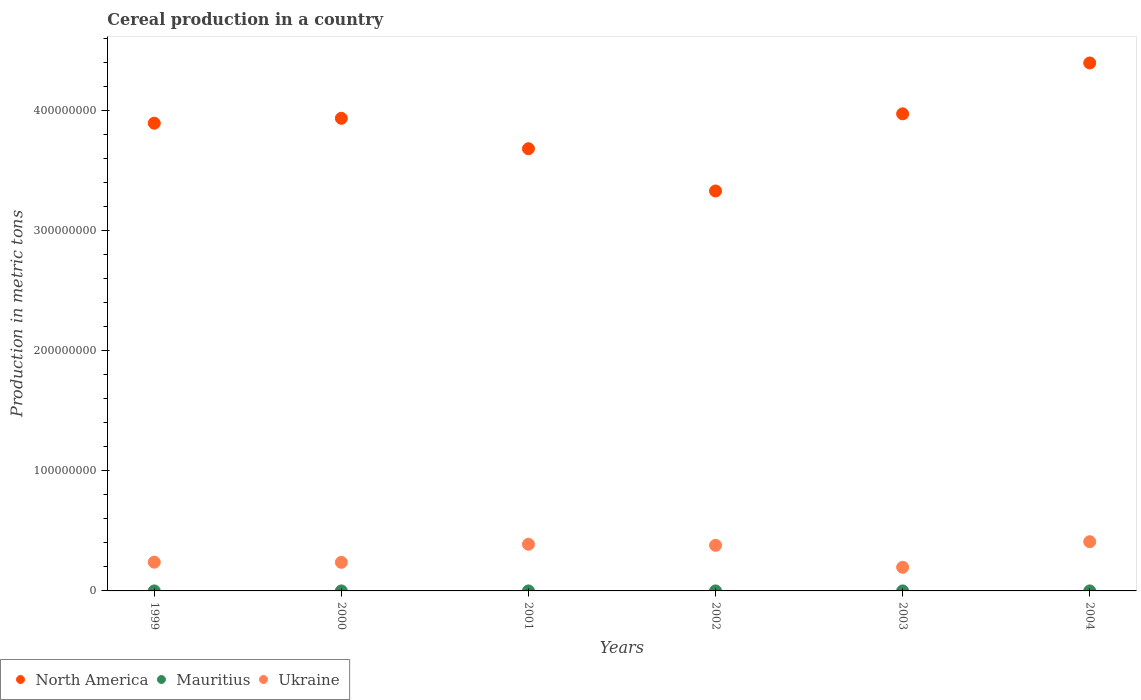What is the total cereal production in Ukraine in 2002?
Provide a short and direct response. 3.80e+07. Across all years, what is the maximum total cereal production in North America?
Ensure brevity in your answer.  4.40e+08. Across all years, what is the minimum total cereal production in North America?
Your answer should be compact. 3.33e+08. In which year was the total cereal production in Mauritius maximum?
Provide a short and direct response. 2000. What is the total total cereal production in Mauritius in the graph?
Offer a terse response. 2054. What is the difference between the total cereal production in Ukraine in 2002 and that in 2004?
Ensure brevity in your answer.  -3.00e+06. What is the difference between the total cereal production in Mauritius in 2003 and the total cereal production in North America in 1999?
Provide a succinct answer. -3.90e+08. What is the average total cereal production in Ukraine per year?
Your answer should be compact. 3.09e+07. In the year 2001, what is the difference between the total cereal production in Ukraine and total cereal production in North America?
Your response must be concise. -3.29e+08. What is the ratio of the total cereal production in Ukraine in 1999 to that in 2003?
Offer a very short reply. 1.22. Is the total cereal production in North America in 2000 less than that in 2004?
Your response must be concise. Yes. Is the difference between the total cereal production in Ukraine in 1999 and 2000 greater than the difference between the total cereal production in North America in 1999 and 2000?
Your response must be concise. Yes. What is the difference between the highest and the second highest total cereal production in Ukraine?
Make the answer very short. 2.12e+06. What is the difference between the highest and the lowest total cereal production in North America?
Your answer should be very brief. 1.07e+08. In how many years, is the total cereal production in Ukraine greater than the average total cereal production in Ukraine taken over all years?
Give a very brief answer. 3. Is the sum of the total cereal production in Mauritius in 2000 and 2004 greater than the maximum total cereal production in Ukraine across all years?
Give a very brief answer. No. Is it the case that in every year, the sum of the total cereal production in Ukraine and total cereal production in Mauritius  is greater than the total cereal production in North America?
Your response must be concise. No. Does the total cereal production in North America monotonically increase over the years?
Your response must be concise. No. What is the difference between two consecutive major ticks on the Y-axis?
Your answer should be compact. 1.00e+08. Are the values on the major ticks of Y-axis written in scientific E-notation?
Your response must be concise. No. Where does the legend appear in the graph?
Your response must be concise. Bottom left. What is the title of the graph?
Your answer should be very brief. Cereal production in a country. Does "Senegal" appear as one of the legend labels in the graph?
Offer a terse response. No. What is the label or title of the X-axis?
Offer a terse response. Years. What is the label or title of the Y-axis?
Your response must be concise. Production in metric tons. What is the Production in metric tons in North America in 1999?
Provide a succinct answer. 3.90e+08. What is the Production in metric tons of Mauritius in 1999?
Give a very brief answer. 201. What is the Production in metric tons of Ukraine in 1999?
Give a very brief answer. 2.39e+07. What is the Production in metric tons in North America in 2000?
Give a very brief answer. 3.94e+08. What is the Production in metric tons in Mauritius in 2000?
Provide a short and direct response. 623. What is the Production in metric tons in Ukraine in 2000?
Make the answer very short. 2.38e+07. What is the Production in metric tons of North America in 2001?
Keep it short and to the point. 3.68e+08. What is the Production in metric tons of Mauritius in 2001?
Your answer should be compact. 389. What is the Production in metric tons in Ukraine in 2001?
Your response must be concise. 3.89e+07. What is the Production in metric tons in North America in 2002?
Offer a very short reply. 3.33e+08. What is the Production in metric tons in Mauritius in 2002?
Your response must be concise. 295. What is the Production in metric tons in Ukraine in 2002?
Offer a terse response. 3.80e+07. What is the Production in metric tons in North America in 2003?
Offer a terse response. 3.97e+08. What is the Production in metric tons of Mauritius in 2003?
Offer a terse response. 177. What is the Production in metric tons in Ukraine in 2003?
Keep it short and to the point. 1.97e+07. What is the Production in metric tons in North America in 2004?
Give a very brief answer. 4.40e+08. What is the Production in metric tons of Mauritius in 2004?
Make the answer very short. 369. What is the Production in metric tons in Ukraine in 2004?
Your response must be concise. 4.10e+07. Across all years, what is the maximum Production in metric tons in North America?
Provide a succinct answer. 4.40e+08. Across all years, what is the maximum Production in metric tons of Mauritius?
Your response must be concise. 623. Across all years, what is the maximum Production in metric tons of Ukraine?
Your response must be concise. 4.10e+07. Across all years, what is the minimum Production in metric tons of North America?
Make the answer very short. 3.33e+08. Across all years, what is the minimum Production in metric tons of Mauritius?
Provide a short and direct response. 177. Across all years, what is the minimum Production in metric tons in Ukraine?
Offer a very short reply. 1.97e+07. What is the total Production in metric tons of North America in the graph?
Offer a very short reply. 2.32e+09. What is the total Production in metric tons in Mauritius in the graph?
Make the answer very short. 2054. What is the total Production in metric tons in Ukraine in the graph?
Your answer should be very brief. 1.85e+08. What is the difference between the Production in metric tons in North America in 1999 and that in 2000?
Ensure brevity in your answer.  -4.09e+06. What is the difference between the Production in metric tons in Mauritius in 1999 and that in 2000?
Offer a terse response. -422. What is the difference between the Production in metric tons of Ukraine in 1999 and that in 2000?
Offer a very short reply. 1.43e+05. What is the difference between the Production in metric tons of North America in 1999 and that in 2001?
Provide a succinct answer. 2.13e+07. What is the difference between the Production in metric tons in Mauritius in 1999 and that in 2001?
Ensure brevity in your answer.  -188. What is the difference between the Production in metric tons of Ukraine in 1999 and that in 2001?
Your answer should be compact. -1.49e+07. What is the difference between the Production in metric tons of North America in 1999 and that in 2002?
Ensure brevity in your answer.  5.65e+07. What is the difference between the Production in metric tons in Mauritius in 1999 and that in 2002?
Your response must be concise. -94. What is the difference between the Production in metric tons of Ukraine in 1999 and that in 2002?
Provide a short and direct response. -1.40e+07. What is the difference between the Production in metric tons in North America in 1999 and that in 2003?
Provide a short and direct response. -7.80e+06. What is the difference between the Production in metric tons of Mauritius in 1999 and that in 2003?
Ensure brevity in your answer.  24. What is the difference between the Production in metric tons of Ukraine in 1999 and that in 2003?
Offer a very short reply. 4.29e+06. What is the difference between the Production in metric tons in North America in 1999 and that in 2004?
Your answer should be very brief. -5.02e+07. What is the difference between the Production in metric tons of Mauritius in 1999 and that in 2004?
Provide a short and direct response. -168. What is the difference between the Production in metric tons in Ukraine in 1999 and that in 2004?
Provide a succinct answer. -1.70e+07. What is the difference between the Production in metric tons of North America in 2000 and that in 2001?
Provide a short and direct response. 2.53e+07. What is the difference between the Production in metric tons of Mauritius in 2000 and that in 2001?
Provide a succinct answer. 234. What is the difference between the Production in metric tons of Ukraine in 2000 and that in 2001?
Keep it short and to the point. -1.51e+07. What is the difference between the Production in metric tons in North America in 2000 and that in 2002?
Provide a succinct answer. 6.05e+07. What is the difference between the Production in metric tons in Mauritius in 2000 and that in 2002?
Make the answer very short. 328. What is the difference between the Production in metric tons of Ukraine in 2000 and that in 2002?
Provide a succinct answer. -1.42e+07. What is the difference between the Production in metric tons in North America in 2000 and that in 2003?
Ensure brevity in your answer.  -3.71e+06. What is the difference between the Production in metric tons of Mauritius in 2000 and that in 2003?
Provide a short and direct response. 446. What is the difference between the Production in metric tons in Ukraine in 2000 and that in 2003?
Your answer should be very brief. 4.14e+06. What is the difference between the Production in metric tons in North America in 2000 and that in 2004?
Offer a very short reply. -4.61e+07. What is the difference between the Production in metric tons in Mauritius in 2000 and that in 2004?
Ensure brevity in your answer.  254. What is the difference between the Production in metric tons in Ukraine in 2000 and that in 2004?
Offer a terse response. -1.72e+07. What is the difference between the Production in metric tons in North America in 2001 and that in 2002?
Your response must be concise. 3.52e+07. What is the difference between the Production in metric tons in Mauritius in 2001 and that in 2002?
Offer a terse response. 94. What is the difference between the Production in metric tons of Ukraine in 2001 and that in 2002?
Make the answer very short. 8.84e+05. What is the difference between the Production in metric tons in North America in 2001 and that in 2003?
Keep it short and to the point. -2.91e+07. What is the difference between the Production in metric tons of Mauritius in 2001 and that in 2003?
Make the answer very short. 212. What is the difference between the Production in metric tons in Ukraine in 2001 and that in 2003?
Ensure brevity in your answer.  1.92e+07. What is the difference between the Production in metric tons of North America in 2001 and that in 2004?
Ensure brevity in your answer.  -7.14e+07. What is the difference between the Production in metric tons in Mauritius in 2001 and that in 2004?
Make the answer very short. 20. What is the difference between the Production in metric tons in Ukraine in 2001 and that in 2004?
Give a very brief answer. -2.12e+06. What is the difference between the Production in metric tons of North America in 2002 and that in 2003?
Your response must be concise. -6.43e+07. What is the difference between the Production in metric tons of Mauritius in 2002 and that in 2003?
Your response must be concise. 118. What is the difference between the Production in metric tons in Ukraine in 2002 and that in 2003?
Your answer should be compact. 1.83e+07. What is the difference between the Production in metric tons of North America in 2002 and that in 2004?
Your answer should be very brief. -1.07e+08. What is the difference between the Production in metric tons in Mauritius in 2002 and that in 2004?
Provide a succinct answer. -74. What is the difference between the Production in metric tons in Ukraine in 2002 and that in 2004?
Give a very brief answer. -3.00e+06. What is the difference between the Production in metric tons in North America in 2003 and that in 2004?
Your response must be concise. -4.24e+07. What is the difference between the Production in metric tons of Mauritius in 2003 and that in 2004?
Offer a very short reply. -192. What is the difference between the Production in metric tons of Ukraine in 2003 and that in 2004?
Offer a terse response. -2.13e+07. What is the difference between the Production in metric tons in North America in 1999 and the Production in metric tons in Mauritius in 2000?
Offer a very short reply. 3.90e+08. What is the difference between the Production in metric tons in North America in 1999 and the Production in metric tons in Ukraine in 2000?
Provide a short and direct response. 3.66e+08. What is the difference between the Production in metric tons in Mauritius in 1999 and the Production in metric tons in Ukraine in 2000?
Your answer should be very brief. -2.38e+07. What is the difference between the Production in metric tons in North America in 1999 and the Production in metric tons in Mauritius in 2001?
Provide a short and direct response. 3.90e+08. What is the difference between the Production in metric tons in North America in 1999 and the Production in metric tons in Ukraine in 2001?
Provide a succinct answer. 3.51e+08. What is the difference between the Production in metric tons in Mauritius in 1999 and the Production in metric tons in Ukraine in 2001?
Your answer should be compact. -3.89e+07. What is the difference between the Production in metric tons in North America in 1999 and the Production in metric tons in Mauritius in 2002?
Your answer should be very brief. 3.90e+08. What is the difference between the Production in metric tons in North America in 1999 and the Production in metric tons in Ukraine in 2002?
Your answer should be compact. 3.52e+08. What is the difference between the Production in metric tons of Mauritius in 1999 and the Production in metric tons of Ukraine in 2002?
Provide a short and direct response. -3.80e+07. What is the difference between the Production in metric tons in North America in 1999 and the Production in metric tons in Mauritius in 2003?
Provide a short and direct response. 3.90e+08. What is the difference between the Production in metric tons in North America in 1999 and the Production in metric tons in Ukraine in 2003?
Offer a terse response. 3.70e+08. What is the difference between the Production in metric tons in Mauritius in 1999 and the Production in metric tons in Ukraine in 2003?
Give a very brief answer. -1.97e+07. What is the difference between the Production in metric tons in North America in 1999 and the Production in metric tons in Mauritius in 2004?
Make the answer very short. 3.90e+08. What is the difference between the Production in metric tons of North America in 1999 and the Production in metric tons of Ukraine in 2004?
Keep it short and to the point. 3.49e+08. What is the difference between the Production in metric tons in Mauritius in 1999 and the Production in metric tons in Ukraine in 2004?
Keep it short and to the point. -4.10e+07. What is the difference between the Production in metric tons in North America in 2000 and the Production in metric tons in Mauritius in 2001?
Ensure brevity in your answer.  3.94e+08. What is the difference between the Production in metric tons in North America in 2000 and the Production in metric tons in Ukraine in 2001?
Your response must be concise. 3.55e+08. What is the difference between the Production in metric tons of Mauritius in 2000 and the Production in metric tons of Ukraine in 2001?
Offer a very short reply. -3.89e+07. What is the difference between the Production in metric tons in North America in 2000 and the Production in metric tons in Mauritius in 2002?
Your answer should be compact. 3.94e+08. What is the difference between the Production in metric tons in North America in 2000 and the Production in metric tons in Ukraine in 2002?
Keep it short and to the point. 3.56e+08. What is the difference between the Production in metric tons of Mauritius in 2000 and the Production in metric tons of Ukraine in 2002?
Offer a terse response. -3.80e+07. What is the difference between the Production in metric tons of North America in 2000 and the Production in metric tons of Mauritius in 2003?
Ensure brevity in your answer.  3.94e+08. What is the difference between the Production in metric tons in North America in 2000 and the Production in metric tons in Ukraine in 2003?
Offer a very short reply. 3.74e+08. What is the difference between the Production in metric tons in Mauritius in 2000 and the Production in metric tons in Ukraine in 2003?
Offer a very short reply. -1.97e+07. What is the difference between the Production in metric tons in North America in 2000 and the Production in metric tons in Mauritius in 2004?
Offer a terse response. 3.94e+08. What is the difference between the Production in metric tons in North America in 2000 and the Production in metric tons in Ukraine in 2004?
Provide a short and direct response. 3.53e+08. What is the difference between the Production in metric tons in Mauritius in 2000 and the Production in metric tons in Ukraine in 2004?
Keep it short and to the point. -4.10e+07. What is the difference between the Production in metric tons of North America in 2001 and the Production in metric tons of Mauritius in 2002?
Your answer should be compact. 3.68e+08. What is the difference between the Production in metric tons in North America in 2001 and the Production in metric tons in Ukraine in 2002?
Your answer should be very brief. 3.30e+08. What is the difference between the Production in metric tons of Mauritius in 2001 and the Production in metric tons of Ukraine in 2002?
Provide a short and direct response. -3.80e+07. What is the difference between the Production in metric tons in North America in 2001 and the Production in metric tons in Mauritius in 2003?
Provide a short and direct response. 3.68e+08. What is the difference between the Production in metric tons of North America in 2001 and the Production in metric tons of Ukraine in 2003?
Ensure brevity in your answer.  3.49e+08. What is the difference between the Production in metric tons of Mauritius in 2001 and the Production in metric tons of Ukraine in 2003?
Provide a succinct answer. -1.97e+07. What is the difference between the Production in metric tons in North America in 2001 and the Production in metric tons in Mauritius in 2004?
Give a very brief answer. 3.68e+08. What is the difference between the Production in metric tons in North America in 2001 and the Production in metric tons in Ukraine in 2004?
Make the answer very short. 3.27e+08. What is the difference between the Production in metric tons in Mauritius in 2001 and the Production in metric tons in Ukraine in 2004?
Your answer should be very brief. -4.10e+07. What is the difference between the Production in metric tons of North America in 2002 and the Production in metric tons of Mauritius in 2003?
Offer a terse response. 3.33e+08. What is the difference between the Production in metric tons of North America in 2002 and the Production in metric tons of Ukraine in 2003?
Provide a short and direct response. 3.14e+08. What is the difference between the Production in metric tons of Mauritius in 2002 and the Production in metric tons of Ukraine in 2003?
Give a very brief answer. -1.97e+07. What is the difference between the Production in metric tons of North America in 2002 and the Production in metric tons of Mauritius in 2004?
Provide a short and direct response. 3.33e+08. What is the difference between the Production in metric tons in North America in 2002 and the Production in metric tons in Ukraine in 2004?
Keep it short and to the point. 2.92e+08. What is the difference between the Production in metric tons of Mauritius in 2002 and the Production in metric tons of Ukraine in 2004?
Ensure brevity in your answer.  -4.10e+07. What is the difference between the Production in metric tons of North America in 2003 and the Production in metric tons of Mauritius in 2004?
Your response must be concise. 3.97e+08. What is the difference between the Production in metric tons in North America in 2003 and the Production in metric tons in Ukraine in 2004?
Your answer should be compact. 3.56e+08. What is the difference between the Production in metric tons in Mauritius in 2003 and the Production in metric tons in Ukraine in 2004?
Give a very brief answer. -4.10e+07. What is the average Production in metric tons of North America per year?
Your answer should be very brief. 3.87e+08. What is the average Production in metric tons of Mauritius per year?
Make the answer very short. 342.33. What is the average Production in metric tons in Ukraine per year?
Make the answer very short. 3.09e+07. In the year 1999, what is the difference between the Production in metric tons of North America and Production in metric tons of Mauritius?
Your answer should be very brief. 3.90e+08. In the year 1999, what is the difference between the Production in metric tons in North America and Production in metric tons in Ukraine?
Provide a short and direct response. 3.66e+08. In the year 1999, what is the difference between the Production in metric tons of Mauritius and Production in metric tons of Ukraine?
Ensure brevity in your answer.  -2.39e+07. In the year 2000, what is the difference between the Production in metric tons of North America and Production in metric tons of Mauritius?
Give a very brief answer. 3.94e+08. In the year 2000, what is the difference between the Production in metric tons in North America and Production in metric tons in Ukraine?
Provide a succinct answer. 3.70e+08. In the year 2000, what is the difference between the Production in metric tons in Mauritius and Production in metric tons in Ukraine?
Offer a very short reply. -2.38e+07. In the year 2001, what is the difference between the Production in metric tons of North America and Production in metric tons of Mauritius?
Offer a very short reply. 3.68e+08. In the year 2001, what is the difference between the Production in metric tons in North America and Production in metric tons in Ukraine?
Your answer should be very brief. 3.29e+08. In the year 2001, what is the difference between the Production in metric tons in Mauritius and Production in metric tons in Ukraine?
Ensure brevity in your answer.  -3.89e+07. In the year 2002, what is the difference between the Production in metric tons in North America and Production in metric tons in Mauritius?
Give a very brief answer. 3.33e+08. In the year 2002, what is the difference between the Production in metric tons of North America and Production in metric tons of Ukraine?
Make the answer very short. 2.95e+08. In the year 2002, what is the difference between the Production in metric tons of Mauritius and Production in metric tons of Ukraine?
Your answer should be very brief. -3.80e+07. In the year 2003, what is the difference between the Production in metric tons in North America and Production in metric tons in Mauritius?
Offer a terse response. 3.97e+08. In the year 2003, what is the difference between the Production in metric tons in North America and Production in metric tons in Ukraine?
Ensure brevity in your answer.  3.78e+08. In the year 2003, what is the difference between the Production in metric tons of Mauritius and Production in metric tons of Ukraine?
Provide a succinct answer. -1.97e+07. In the year 2004, what is the difference between the Production in metric tons of North America and Production in metric tons of Mauritius?
Your response must be concise. 4.40e+08. In the year 2004, what is the difference between the Production in metric tons of North America and Production in metric tons of Ukraine?
Provide a short and direct response. 3.99e+08. In the year 2004, what is the difference between the Production in metric tons of Mauritius and Production in metric tons of Ukraine?
Provide a short and direct response. -4.10e+07. What is the ratio of the Production in metric tons of North America in 1999 to that in 2000?
Keep it short and to the point. 0.99. What is the ratio of the Production in metric tons of Mauritius in 1999 to that in 2000?
Keep it short and to the point. 0.32. What is the ratio of the Production in metric tons of North America in 1999 to that in 2001?
Offer a terse response. 1.06. What is the ratio of the Production in metric tons of Mauritius in 1999 to that in 2001?
Make the answer very short. 0.52. What is the ratio of the Production in metric tons of Ukraine in 1999 to that in 2001?
Offer a very short reply. 0.62. What is the ratio of the Production in metric tons of North America in 1999 to that in 2002?
Keep it short and to the point. 1.17. What is the ratio of the Production in metric tons in Mauritius in 1999 to that in 2002?
Provide a short and direct response. 0.68. What is the ratio of the Production in metric tons in Ukraine in 1999 to that in 2002?
Offer a terse response. 0.63. What is the ratio of the Production in metric tons in North America in 1999 to that in 2003?
Give a very brief answer. 0.98. What is the ratio of the Production in metric tons in Mauritius in 1999 to that in 2003?
Give a very brief answer. 1.14. What is the ratio of the Production in metric tons of Ukraine in 1999 to that in 2003?
Your answer should be very brief. 1.22. What is the ratio of the Production in metric tons of North America in 1999 to that in 2004?
Your answer should be compact. 0.89. What is the ratio of the Production in metric tons of Mauritius in 1999 to that in 2004?
Make the answer very short. 0.54. What is the ratio of the Production in metric tons of Ukraine in 1999 to that in 2004?
Provide a succinct answer. 0.58. What is the ratio of the Production in metric tons of North America in 2000 to that in 2001?
Provide a short and direct response. 1.07. What is the ratio of the Production in metric tons in Mauritius in 2000 to that in 2001?
Your answer should be compact. 1.6. What is the ratio of the Production in metric tons in Ukraine in 2000 to that in 2001?
Give a very brief answer. 0.61. What is the ratio of the Production in metric tons in North America in 2000 to that in 2002?
Offer a terse response. 1.18. What is the ratio of the Production in metric tons of Mauritius in 2000 to that in 2002?
Provide a succinct answer. 2.11. What is the ratio of the Production in metric tons in Ukraine in 2000 to that in 2002?
Your response must be concise. 0.63. What is the ratio of the Production in metric tons of Mauritius in 2000 to that in 2003?
Your answer should be very brief. 3.52. What is the ratio of the Production in metric tons in Ukraine in 2000 to that in 2003?
Your answer should be compact. 1.21. What is the ratio of the Production in metric tons in North America in 2000 to that in 2004?
Offer a terse response. 0.9. What is the ratio of the Production in metric tons in Mauritius in 2000 to that in 2004?
Give a very brief answer. 1.69. What is the ratio of the Production in metric tons of Ukraine in 2000 to that in 2004?
Your response must be concise. 0.58. What is the ratio of the Production in metric tons in North America in 2001 to that in 2002?
Offer a very short reply. 1.11. What is the ratio of the Production in metric tons of Mauritius in 2001 to that in 2002?
Your answer should be very brief. 1.32. What is the ratio of the Production in metric tons in Ukraine in 2001 to that in 2002?
Ensure brevity in your answer.  1.02. What is the ratio of the Production in metric tons of North America in 2001 to that in 2003?
Keep it short and to the point. 0.93. What is the ratio of the Production in metric tons in Mauritius in 2001 to that in 2003?
Ensure brevity in your answer.  2.2. What is the ratio of the Production in metric tons of Ukraine in 2001 to that in 2003?
Provide a short and direct response. 1.98. What is the ratio of the Production in metric tons of North America in 2001 to that in 2004?
Your answer should be compact. 0.84. What is the ratio of the Production in metric tons in Mauritius in 2001 to that in 2004?
Your response must be concise. 1.05. What is the ratio of the Production in metric tons of Ukraine in 2001 to that in 2004?
Give a very brief answer. 0.95. What is the ratio of the Production in metric tons in North America in 2002 to that in 2003?
Offer a very short reply. 0.84. What is the ratio of the Production in metric tons in Mauritius in 2002 to that in 2003?
Provide a succinct answer. 1.67. What is the ratio of the Production in metric tons in Ukraine in 2002 to that in 2003?
Ensure brevity in your answer.  1.93. What is the ratio of the Production in metric tons of North America in 2002 to that in 2004?
Offer a very short reply. 0.76. What is the ratio of the Production in metric tons in Mauritius in 2002 to that in 2004?
Your answer should be compact. 0.8. What is the ratio of the Production in metric tons in Ukraine in 2002 to that in 2004?
Your response must be concise. 0.93. What is the ratio of the Production in metric tons in North America in 2003 to that in 2004?
Make the answer very short. 0.9. What is the ratio of the Production in metric tons in Mauritius in 2003 to that in 2004?
Offer a terse response. 0.48. What is the ratio of the Production in metric tons in Ukraine in 2003 to that in 2004?
Keep it short and to the point. 0.48. What is the difference between the highest and the second highest Production in metric tons of North America?
Give a very brief answer. 4.24e+07. What is the difference between the highest and the second highest Production in metric tons of Mauritius?
Give a very brief answer. 234. What is the difference between the highest and the second highest Production in metric tons of Ukraine?
Your response must be concise. 2.12e+06. What is the difference between the highest and the lowest Production in metric tons in North America?
Offer a terse response. 1.07e+08. What is the difference between the highest and the lowest Production in metric tons of Mauritius?
Your response must be concise. 446. What is the difference between the highest and the lowest Production in metric tons of Ukraine?
Make the answer very short. 2.13e+07. 